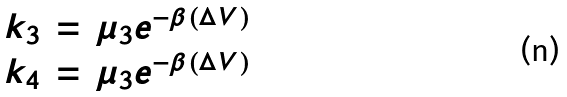<formula> <loc_0><loc_0><loc_500><loc_500>\begin{array} { c c c } k _ { 3 } & = & \mu _ { 3 } e ^ { - \beta ( \Delta V ) } \\ k _ { 4 } & = & \mu _ { 3 } e ^ { - \beta ( \Delta V ) } \\ \end{array}</formula> 